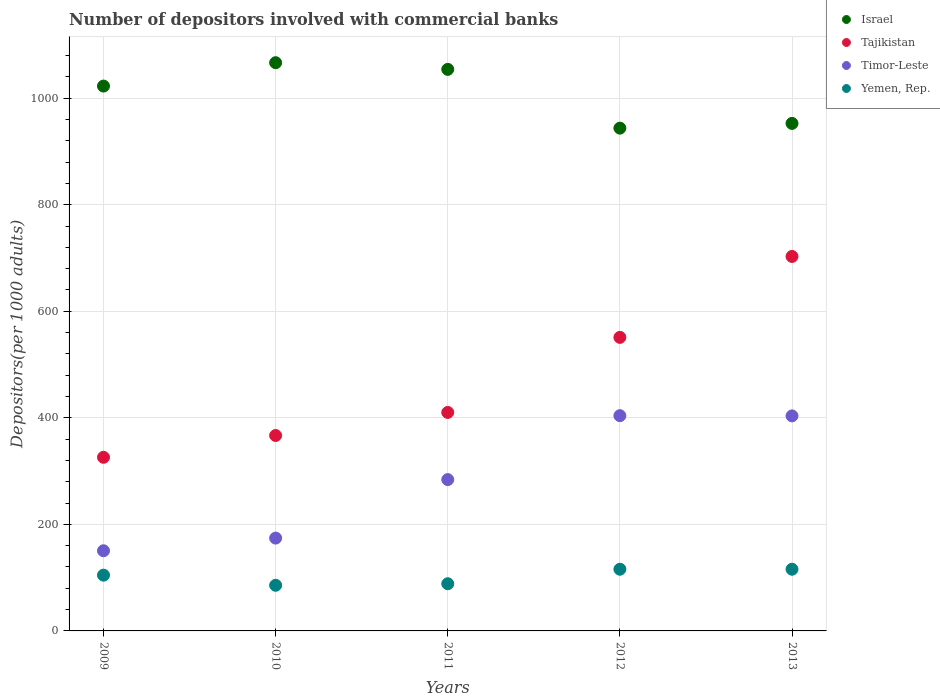How many different coloured dotlines are there?
Provide a succinct answer. 4. Is the number of dotlines equal to the number of legend labels?
Provide a short and direct response. Yes. What is the number of depositors involved with commercial banks in Tajikistan in 2011?
Ensure brevity in your answer.  410.1. Across all years, what is the maximum number of depositors involved with commercial banks in Israel?
Keep it short and to the point. 1066.56. Across all years, what is the minimum number of depositors involved with commercial banks in Yemen, Rep.?
Give a very brief answer. 85.68. In which year was the number of depositors involved with commercial banks in Timor-Leste maximum?
Ensure brevity in your answer.  2012. What is the total number of depositors involved with commercial banks in Yemen, Rep. in the graph?
Offer a terse response. 510.5. What is the difference between the number of depositors involved with commercial banks in Tajikistan in 2010 and that in 2012?
Give a very brief answer. -184.2. What is the difference between the number of depositors involved with commercial banks in Israel in 2011 and the number of depositors involved with commercial banks in Tajikistan in 2012?
Your response must be concise. 503.07. What is the average number of depositors involved with commercial banks in Timor-Leste per year?
Provide a short and direct response. 283.28. In the year 2012, what is the difference between the number of depositors involved with commercial banks in Timor-Leste and number of depositors involved with commercial banks in Yemen, Rep.?
Offer a terse response. 288.23. In how many years, is the number of depositors involved with commercial banks in Tajikistan greater than 1000?
Offer a terse response. 0. What is the ratio of the number of depositors involved with commercial banks in Timor-Leste in 2011 to that in 2012?
Offer a very short reply. 0.7. What is the difference between the highest and the second highest number of depositors involved with commercial banks in Timor-Leste?
Give a very brief answer. 0.38. What is the difference between the highest and the lowest number of depositors involved with commercial banks in Timor-Leste?
Offer a very short reply. 253.56. Is it the case that in every year, the sum of the number of depositors involved with commercial banks in Israel and number of depositors involved with commercial banks in Timor-Leste  is greater than the sum of number of depositors involved with commercial banks in Yemen, Rep. and number of depositors involved with commercial banks in Tajikistan?
Keep it short and to the point. Yes. Does the number of depositors involved with commercial banks in Israel monotonically increase over the years?
Your response must be concise. No. Is the number of depositors involved with commercial banks in Yemen, Rep. strictly less than the number of depositors involved with commercial banks in Timor-Leste over the years?
Keep it short and to the point. Yes. How many years are there in the graph?
Offer a terse response. 5. Where does the legend appear in the graph?
Your answer should be compact. Top right. What is the title of the graph?
Offer a terse response. Number of depositors involved with commercial banks. Does "Mexico" appear as one of the legend labels in the graph?
Make the answer very short. No. What is the label or title of the X-axis?
Offer a very short reply. Years. What is the label or title of the Y-axis?
Provide a succinct answer. Depositors(per 1000 adults). What is the Depositors(per 1000 adults) in Israel in 2009?
Offer a very short reply. 1022.7. What is the Depositors(per 1000 adults) of Tajikistan in 2009?
Offer a very short reply. 325.89. What is the Depositors(per 1000 adults) in Timor-Leste in 2009?
Your answer should be compact. 150.45. What is the Depositors(per 1000 adults) of Yemen, Rep. in 2009?
Your response must be concise. 104.68. What is the Depositors(per 1000 adults) of Israel in 2010?
Offer a terse response. 1066.56. What is the Depositors(per 1000 adults) in Tajikistan in 2010?
Make the answer very short. 366.8. What is the Depositors(per 1000 adults) of Timor-Leste in 2010?
Make the answer very short. 174.21. What is the Depositors(per 1000 adults) of Yemen, Rep. in 2010?
Give a very brief answer. 85.68. What is the Depositors(per 1000 adults) of Israel in 2011?
Ensure brevity in your answer.  1054.06. What is the Depositors(per 1000 adults) in Tajikistan in 2011?
Provide a short and direct response. 410.1. What is the Depositors(per 1000 adults) in Timor-Leste in 2011?
Your response must be concise. 284.07. What is the Depositors(per 1000 adults) in Yemen, Rep. in 2011?
Ensure brevity in your answer.  88.57. What is the Depositors(per 1000 adults) of Israel in 2012?
Your answer should be very brief. 943.72. What is the Depositors(per 1000 adults) in Tajikistan in 2012?
Keep it short and to the point. 550.99. What is the Depositors(per 1000 adults) in Timor-Leste in 2012?
Make the answer very short. 404.02. What is the Depositors(per 1000 adults) of Yemen, Rep. in 2012?
Keep it short and to the point. 115.78. What is the Depositors(per 1000 adults) in Israel in 2013?
Give a very brief answer. 952.62. What is the Depositors(per 1000 adults) in Tajikistan in 2013?
Provide a succinct answer. 702.89. What is the Depositors(per 1000 adults) in Timor-Leste in 2013?
Your answer should be very brief. 403.64. What is the Depositors(per 1000 adults) in Yemen, Rep. in 2013?
Your answer should be compact. 115.79. Across all years, what is the maximum Depositors(per 1000 adults) in Israel?
Provide a succinct answer. 1066.56. Across all years, what is the maximum Depositors(per 1000 adults) in Tajikistan?
Make the answer very short. 702.89. Across all years, what is the maximum Depositors(per 1000 adults) of Timor-Leste?
Provide a succinct answer. 404.02. Across all years, what is the maximum Depositors(per 1000 adults) in Yemen, Rep.?
Keep it short and to the point. 115.79. Across all years, what is the minimum Depositors(per 1000 adults) of Israel?
Give a very brief answer. 943.72. Across all years, what is the minimum Depositors(per 1000 adults) in Tajikistan?
Your answer should be compact. 325.89. Across all years, what is the minimum Depositors(per 1000 adults) in Timor-Leste?
Offer a terse response. 150.45. Across all years, what is the minimum Depositors(per 1000 adults) in Yemen, Rep.?
Keep it short and to the point. 85.68. What is the total Depositors(per 1000 adults) in Israel in the graph?
Ensure brevity in your answer.  5039.66. What is the total Depositors(per 1000 adults) in Tajikistan in the graph?
Your answer should be compact. 2356.67. What is the total Depositors(per 1000 adults) of Timor-Leste in the graph?
Ensure brevity in your answer.  1416.39. What is the total Depositors(per 1000 adults) in Yemen, Rep. in the graph?
Keep it short and to the point. 510.5. What is the difference between the Depositors(per 1000 adults) of Israel in 2009 and that in 2010?
Provide a short and direct response. -43.86. What is the difference between the Depositors(per 1000 adults) in Tajikistan in 2009 and that in 2010?
Your answer should be compact. -40.9. What is the difference between the Depositors(per 1000 adults) in Timor-Leste in 2009 and that in 2010?
Make the answer very short. -23.76. What is the difference between the Depositors(per 1000 adults) in Yemen, Rep. in 2009 and that in 2010?
Your answer should be compact. 19. What is the difference between the Depositors(per 1000 adults) in Israel in 2009 and that in 2011?
Offer a very short reply. -31.36. What is the difference between the Depositors(per 1000 adults) of Tajikistan in 2009 and that in 2011?
Make the answer very short. -84.21. What is the difference between the Depositors(per 1000 adults) of Timor-Leste in 2009 and that in 2011?
Your answer should be very brief. -133.62. What is the difference between the Depositors(per 1000 adults) of Yemen, Rep. in 2009 and that in 2011?
Provide a short and direct response. 16.11. What is the difference between the Depositors(per 1000 adults) of Israel in 2009 and that in 2012?
Your response must be concise. 78.98. What is the difference between the Depositors(per 1000 adults) in Tajikistan in 2009 and that in 2012?
Provide a succinct answer. -225.1. What is the difference between the Depositors(per 1000 adults) in Timor-Leste in 2009 and that in 2012?
Offer a very short reply. -253.56. What is the difference between the Depositors(per 1000 adults) in Yemen, Rep. in 2009 and that in 2012?
Make the answer very short. -11.1. What is the difference between the Depositors(per 1000 adults) of Israel in 2009 and that in 2013?
Your response must be concise. 70.08. What is the difference between the Depositors(per 1000 adults) of Tajikistan in 2009 and that in 2013?
Your answer should be compact. -377. What is the difference between the Depositors(per 1000 adults) of Timor-Leste in 2009 and that in 2013?
Your answer should be compact. -253.19. What is the difference between the Depositors(per 1000 adults) of Yemen, Rep. in 2009 and that in 2013?
Offer a very short reply. -11.11. What is the difference between the Depositors(per 1000 adults) in Israel in 2010 and that in 2011?
Offer a terse response. 12.5. What is the difference between the Depositors(per 1000 adults) of Tajikistan in 2010 and that in 2011?
Your answer should be compact. -43.3. What is the difference between the Depositors(per 1000 adults) of Timor-Leste in 2010 and that in 2011?
Provide a short and direct response. -109.86. What is the difference between the Depositors(per 1000 adults) of Yemen, Rep. in 2010 and that in 2011?
Your answer should be compact. -2.89. What is the difference between the Depositors(per 1000 adults) of Israel in 2010 and that in 2012?
Make the answer very short. 122.84. What is the difference between the Depositors(per 1000 adults) of Tajikistan in 2010 and that in 2012?
Your answer should be very brief. -184.2. What is the difference between the Depositors(per 1000 adults) of Timor-Leste in 2010 and that in 2012?
Offer a terse response. -229.8. What is the difference between the Depositors(per 1000 adults) of Yemen, Rep. in 2010 and that in 2012?
Your answer should be very brief. -30.1. What is the difference between the Depositors(per 1000 adults) in Israel in 2010 and that in 2013?
Provide a short and direct response. 113.94. What is the difference between the Depositors(per 1000 adults) of Tajikistan in 2010 and that in 2013?
Provide a short and direct response. -336.09. What is the difference between the Depositors(per 1000 adults) of Timor-Leste in 2010 and that in 2013?
Keep it short and to the point. -229.42. What is the difference between the Depositors(per 1000 adults) of Yemen, Rep. in 2010 and that in 2013?
Ensure brevity in your answer.  -30.11. What is the difference between the Depositors(per 1000 adults) in Israel in 2011 and that in 2012?
Make the answer very short. 110.33. What is the difference between the Depositors(per 1000 adults) in Tajikistan in 2011 and that in 2012?
Your response must be concise. -140.89. What is the difference between the Depositors(per 1000 adults) of Timor-Leste in 2011 and that in 2012?
Provide a short and direct response. -119.94. What is the difference between the Depositors(per 1000 adults) in Yemen, Rep. in 2011 and that in 2012?
Give a very brief answer. -27.21. What is the difference between the Depositors(per 1000 adults) of Israel in 2011 and that in 2013?
Keep it short and to the point. 101.44. What is the difference between the Depositors(per 1000 adults) of Tajikistan in 2011 and that in 2013?
Provide a succinct answer. -292.79. What is the difference between the Depositors(per 1000 adults) in Timor-Leste in 2011 and that in 2013?
Keep it short and to the point. -119.57. What is the difference between the Depositors(per 1000 adults) of Yemen, Rep. in 2011 and that in 2013?
Make the answer very short. -27.22. What is the difference between the Depositors(per 1000 adults) of Israel in 2012 and that in 2013?
Ensure brevity in your answer.  -8.9. What is the difference between the Depositors(per 1000 adults) in Tajikistan in 2012 and that in 2013?
Give a very brief answer. -151.9. What is the difference between the Depositors(per 1000 adults) in Timor-Leste in 2012 and that in 2013?
Ensure brevity in your answer.  0.38. What is the difference between the Depositors(per 1000 adults) of Yemen, Rep. in 2012 and that in 2013?
Your answer should be compact. -0.01. What is the difference between the Depositors(per 1000 adults) in Israel in 2009 and the Depositors(per 1000 adults) in Tajikistan in 2010?
Ensure brevity in your answer.  655.9. What is the difference between the Depositors(per 1000 adults) of Israel in 2009 and the Depositors(per 1000 adults) of Timor-Leste in 2010?
Your answer should be compact. 848.49. What is the difference between the Depositors(per 1000 adults) of Israel in 2009 and the Depositors(per 1000 adults) of Yemen, Rep. in 2010?
Make the answer very short. 937.02. What is the difference between the Depositors(per 1000 adults) of Tajikistan in 2009 and the Depositors(per 1000 adults) of Timor-Leste in 2010?
Your response must be concise. 151.68. What is the difference between the Depositors(per 1000 adults) of Tajikistan in 2009 and the Depositors(per 1000 adults) of Yemen, Rep. in 2010?
Offer a very short reply. 240.21. What is the difference between the Depositors(per 1000 adults) in Timor-Leste in 2009 and the Depositors(per 1000 adults) in Yemen, Rep. in 2010?
Offer a terse response. 64.77. What is the difference between the Depositors(per 1000 adults) of Israel in 2009 and the Depositors(per 1000 adults) of Tajikistan in 2011?
Give a very brief answer. 612.6. What is the difference between the Depositors(per 1000 adults) in Israel in 2009 and the Depositors(per 1000 adults) in Timor-Leste in 2011?
Offer a very short reply. 738.63. What is the difference between the Depositors(per 1000 adults) of Israel in 2009 and the Depositors(per 1000 adults) of Yemen, Rep. in 2011?
Keep it short and to the point. 934.13. What is the difference between the Depositors(per 1000 adults) in Tajikistan in 2009 and the Depositors(per 1000 adults) in Timor-Leste in 2011?
Make the answer very short. 41.82. What is the difference between the Depositors(per 1000 adults) of Tajikistan in 2009 and the Depositors(per 1000 adults) of Yemen, Rep. in 2011?
Your answer should be compact. 237.32. What is the difference between the Depositors(per 1000 adults) in Timor-Leste in 2009 and the Depositors(per 1000 adults) in Yemen, Rep. in 2011?
Ensure brevity in your answer.  61.88. What is the difference between the Depositors(per 1000 adults) in Israel in 2009 and the Depositors(per 1000 adults) in Tajikistan in 2012?
Your response must be concise. 471.71. What is the difference between the Depositors(per 1000 adults) in Israel in 2009 and the Depositors(per 1000 adults) in Timor-Leste in 2012?
Keep it short and to the point. 618.68. What is the difference between the Depositors(per 1000 adults) of Israel in 2009 and the Depositors(per 1000 adults) of Yemen, Rep. in 2012?
Make the answer very short. 906.92. What is the difference between the Depositors(per 1000 adults) in Tajikistan in 2009 and the Depositors(per 1000 adults) in Timor-Leste in 2012?
Provide a short and direct response. -78.12. What is the difference between the Depositors(per 1000 adults) in Tajikistan in 2009 and the Depositors(per 1000 adults) in Yemen, Rep. in 2012?
Provide a succinct answer. 210.11. What is the difference between the Depositors(per 1000 adults) of Timor-Leste in 2009 and the Depositors(per 1000 adults) of Yemen, Rep. in 2012?
Keep it short and to the point. 34.67. What is the difference between the Depositors(per 1000 adults) of Israel in 2009 and the Depositors(per 1000 adults) of Tajikistan in 2013?
Provide a short and direct response. 319.81. What is the difference between the Depositors(per 1000 adults) of Israel in 2009 and the Depositors(per 1000 adults) of Timor-Leste in 2013?
Give a very brief answer. 619.06. What is the difference between the Depositors(per 1000 adults) of Israel in 2009 and the Depositors(per 1000 adults) of Yemen, Rep. in 2013?
Offer a terse response. 906.91. What is the difference between the Depositors(per 1000 adults) of Tajikistan in 2009 and the Depositors(per 1000 adults) of Timor-Leste in 2013?
Provide a short and direct response. -77.75. What is the difference between the Depositors(per 1000 adults) of Tajikistan in 2009 and the Depositors(per 1000 adults) of Yemen, Rep. in 2013?
Your response must be concise. 210.1. What is the difference between the Depositors(per 1000 adults) in Timor-Leste in 2009 and the Depositors(per 1000 adults) in Yemen, Rep. in 2013?
Your response must be concise. 34.66. What is the difference between the Depositors(per 1000 adults) in Israel in 2010 and the Depositors(per 1000 adults) in Tajikistan in 2011?
Provide a short and direct response. 656.46. What is the difference between the Depositors(per 1000 adults) in Israel in 2010 and the Depositors(per 1000 adults) in Timor-Leste in 2011?
Make the answer very short. 782.49. What is the difference between the Depositors(per 1000 adults) of Israel in 2010 and the Depositors(per 1000 adults) of Yemen, Rep. in 2011?
Provide a succinct answer. 977.99. What is the difference between the Depositors(per 1000 adults) of Tajikistan in 2010 and the Depositors(per 1000 adults) of Timor-Leste in 2011?
Give a very brief answer. 82.72. What is the difference between the Depositors(per 1000 adults) in Tajikistan in 2010 and the Depositors(per 1000 adults) in Yemen, Rep. in 2011?
Offer a terse response. 278.23. What is the difference between the Depositors(per 1000 adults) of Timor-Leste in 2010 and the Depositors(per 1000 adults) of Yemen, Rep. in 2011?
Your answer should be compact. 85.64. What is the difference between the Depositors(per 1000 adults) of Israel in 2010 and the Depositors(per 1000 adults) of Tajikistan in 2012?
Provide a succinct answer. 515.57. What is the difference between the Depositors(per 1000 adults) of Israel in 2010 and the Depositors(per 1000 adults) of Timor-Leste in 2012?
Give a very brief answer. 662.54. What is the difference between the Depositors(per 1000 adults) in Israel in 2010 and the Depositors(per 1000 adults) in Yemen, Rep. in 2012?
Provide a succinct answer. 950.78. What is the difference between the Depositors(per 1000 adults) of Tajikistan in 2010 and the Depositors(per 1000 adults) of Timor-Leste in 2012?
Your answer should be compact. -37.22. What is the difference between the Depositors(per 1000 adults) of Tajikistan in 2010 and the Depositors(per 1000 adults) of Yemen, Rep. in 2012?
Your answer should be very brief. 251.01. What is the difference between the Depositors(per 1000 adults) in Timor-Leste in 2010 and the Depositors(per 1000 adults) in Yemen, Rep. in 2012?
Your response must be concise. 58.43. What is the difference between the Depositors(per 1000 adults) in Israel in 2010 and the Depositors(per 1000 adults) in Tajikistan in 2013?
Your response must be concise. 363.67. What is the difference between the Depositors(per 1000 adults) in Israel in 2010 and the Depositors(per 1000 adults) in Timor-Leste in 2013?
Ensure brevity in your answer.  662.92. What is the difference between the Depositors(per 1000 adults) of Israel in 2010 and the Depositors(per 1000 adults) of Yemen, Rep. in 2013?
Provide a short and direct response. 950.77. What is the difference between the Depositors(per 1000 adults) in Tajikistan in 2010 and the Depositors(per 1000 adults) in Timor-Leste in 2013?
Provide a succinct answer. -36.84. What is the difference between the Depositors(per 1000 adults) in Tajikistan in 2010 and the Depositors(per 1000 adults) in Yemen, Rep. in 2013?
Give a very brief answer. 251.01. What is the difference between the Depositors(per 1000 adults) in Timor-Leste in 2010 and the Depositors(per 1000 adults) in Yemen, Rep. in 2013?
Offer a very short reply. 58.43. What is the difference between the Depositors(per 1000 adults) in Israel in 2011 and the Depositors(per 1000 adults) in Tajikistan in 2012?
Your answer should be very brief. 503.07. What is the difference between the Depositors(per 1000 adults) in Israel in 2011 and the Depositors(per 1000 adults) in Timor-Leste in 2012?
Your response must be concise. 650.04. What is the difference between the Depositors(per 1000 adults) in Israel in 2011 and the Depositors(per 1000 adults) in Yemen, Rep. in 2012?
Provide a short and direct response. 938.27. What is the difference between the Depositors(per 1000 adults) in Tajikistan in 2011 and the Depositors(per 1000 adults) in Timor-Leste in 2012?
Provide a short and direct response. 6.08. What is the difference between the Depositors(per 1000 adults) of Tajikistan in 2011 and the Depositors(per 1000 adults) of Yemen, Rep. in 2012?
Provide a succinct answer. 294.32. What is the difference between the Depositors(per 1000 adults) of Timor-Leste in 2011 and the Depositors(per 1000 adults) of Yemen, Rep. in 2012?
Your answer should be compact. 168.29. What is the difference between the Depositors(per 1000 adults) in Israel in 2011 and the Depositors(per 1000 adults) in Tajikistan in 2013?
Offer a very short reply. 351.17. What is the difference between the Depositors(per 1000 adults) in Israel in 2011 and the Depositors(per 1000 adults) in Timor-Leste in 2013?
Ensure brevity in your answer.  650.42. What is the difference between the Depositors(per 1000 adults) of Israel in 2011 and the Depositors(per 1000 adults) of Yemen, Rep. in 2013?
Offer a very short reply. 938.27. What is the difference between the Depositors(per 1000 adults) in Tajikistan in 2011 and the Depositors(per 1000 adults) in Timor-Leste in 2013?
Make the answer very short. 6.46. What is the difference between the Depositors(per 1000 adults) of Tajikistan in 2011 and the Depositors(per 1000 adults) of Yemen, Rep. in 2013?
Give a very brief answer. 294.31. What is the difference between the Depositors(per 1000 adults) of Timor-Leste in 2011 and the Depositors(per 1000 adults) of Yemen, Rep. in 2013?
Make the answer very short. 168.28. What is the difference between the Depositors(per 1000 adults) in Israel in 2012 and the Depositors(per 1000 adults) in Tajikistan in 2013?
Give a very brief answer. 240.83. What is the difference between the Depositors(per 1000 adults) of Israel in 2012 and the Depositors(per 1000 adults) of Timor-Leste in 2013?
Give a very brief answer. 540.09. What is the difference between the Depositors(per 1000 adults) of Israel in 2012 and the Depositors(per 1000 adults) of Yemen, Rep. in 2013?
Ensure brevity in your answer.  827.94. What is the difference between the Depositors(per 1000 adults) of Tajikistan in 2012 and the Depositors(per 1000 adults) of Timor-Leste in 2013?
Offer a terse response. 147.35. What is the difference between the Depositors(per 1000 adults) in Tajikistan in 2012 and the Depositors(per 1000 adults) in Yemen, Rep. in 2013?
Ensure brevity in your answer.  435.2. What is the difference between the Depositors(per 1000 adults) of Timor-Leste in 2012 and the Depositors(per 1000 adults) of Yemen, Rep. in 2013?
Make the answer very short. 288.23. What is the average Depositors(per 1000 adults) of Israel per year?
Your response must be concise. 1007.93. What is the average Depositors(per 1000 adults) in Tajikistan per year?
Ensure brevity in your answer.  471.33. What is the average Depositors(per 1000 adults) of Timor-Leste per year?
Provide a succinct answer. 283.28. What is the average Depositors(per 1000 adults) in Yemen, Rep. per year?
Offer a terse response. 102.1. In the year 2009, what is the difference between the Depositors(per 1000 adults) in Israel and Depositors(per 1000 adults) in Tajikistan?
Your answer should be very brief. 696.81. In the year 2009, what is the difference between the Depositors(per 1000 adults) of Israel and Depositors(per 1000 adults) of Timor-Leste?
Provide a short and direct response. 872.25. In the year 2009, what is the difference between the Depositors(per 1000 adults) in Israel and Depositors(per 1000 adults) in Yemen, Rep.?
Provide a short and direct response. 918.02. In the year 2009, what is the difference between the Depositors(per 1000 adults) of Tajikistan and Depositors(per 1000 adults) of Timor-Leste?
Give a very brief answer. 175.44. In the year 2009, what is the difference between the Depositors(per 1000 adults) in Tajikistan and Depositors(per 1000 adults) in Yemen, Rep.?
Your answer should be very brief. 221.21. In the year 2009, what is the difference between the Depositors(per 1000 adults) of Timor-Leste and Depositors(per 1000 adults) of Yemen, Rep.?
Keep it short and to the point. 45.77. In the year 2010, what is the difference between the Depositors(per 1000 adults) of Israel and Depositors(per 1000 adults) of Tajikistan?
Provide a succinct answer. 699.76. In the year 2010, what is the difference between the Depositors(per 1000 adults) in Israel and Depositors(per 1000 adults) in Timor-Leste?
Make the answer very short. 892.35. In the year 2010, what is the difference between the Depositors(per 1000 adults) in Israel and Depositors(per 1000 adults) in Yemen, Rep.?
Provide a succinct answer. 980.88. In the year 2010, what is the difference between the Depositors(per 1000 adults) of Tajikistan and Depositors(per 1000 adults) of Timor-Leste?
Your answer should be compact. 192.58. In the year 2010, what is the difference between the Depositors(per 1000 adults) of Tajikistan and Depositors(per 1000 adults) of Yemen, Rep.?
Offer a very short reply. 281.11. In the year 2010, what is the difference between the Depositors(per 1000 adults) of Timor-Leste and Depositors(per 1000 adults) of Yemen, Rep.?
Your answer should be compact. 88.53. In the year 2011, what is the difference between the Depositors(per 1000 adults) of Israel and Depositors(per 1000 adults) of Tajikistan?
Your answer should be very brief. 643.96. In the year 2011, what is the difference between the Depositors(per 1000 adults) in Israel and Depositors(per 1000 adults) in Timor-Leste?
Ensure brevity in your answer.  769.99. In the year 2011, what is the difference between the Depositors(per 1000 adults) of Israel and Depositors(per 1000 adults) of Yemen, Rep.?
Give a very brief answer. 965.49. In the year 2011, what is the difference between the Depositors(per 1000 adults) in Tajikistan and Depositors(per 1000 adults) in Timor-Leste?
Provide a succinct answer. 126.03. In the year 2011, what is the difference between the Depositors(per 1000 adults) of Tajikistan and Depositors(per 1000 adults) of Yemen, Rep.?
Your answer should be very brief. 321.53. In the year 2011, what is the difference between the Depositors(per 1000 adults) of Timor-Leste and Depositors(per 1000 adults) of Yemen, Rep.?
Your answer should be very brief. 195.5. In the year 2012, what is the difference between the Depositors(per 1000 adults) of Israel and Depositors(per 1000 adults) of Tajikistan?
Keep it short and to the point. 392.73. In the year 2012, what is the difference between the Depositors(per 1000 adults) of Israel and Depositors(per 1000 adults) of Timor-Leste?
Ensure brevity in your answer.  539.71. In the year 2012, what is the difference between the Depositors(per 1000 adults) in Israel and Depositors(per 1000 adults) in Yemen, Rep.?
Your answer should be very brief. 827.94. In the year 2012, what is the difference between the Depositors(per 1000 adults) in Tajikistan and Depositors(per 1000 adults) in Timor-Leste?
Your answer should be very brief. 146.98. In the year 2012, what is the difference between the Depositors(per 1000 adults) in Tajikistan and Depositors(per 1000 adults) in Yemen, Rep.?
Your answer should be compact. 435.21. In the year 2012, what is the difference between the Depositors(per 1000 adults) of Timor-Leste and Depositors(per 1000 adults) of Yemen, Rep.?
Your response must be concise. 288.23. In the year 2013, what is the difference between the Depositors(per 1000 adults) in Israel and Depositors(per 1000 adults) in Tajikistan?
Your response must be concise. 249.73. In the year 2013, what is the difference between the Depositors(per 1000 adults) of Israel and Depositors(per 1000 adults) of Timor-Leste?
Offer a very short reply. 548.98. In the year 2013, what is the difference between the Depositors(per 1000 adults) of Israel and Depositors(per 1000 adults) of Yemen, Rep.?
Provide a succinct answer. 836.83. In the year 2013, what is the difference between the Depositors(per 1000 adults) in Tajikistan and Depositors(per 1000 adults) in Timor-Leste?
Make the answer very short. 299.25. In the year 2013, what is the difference between the Depositors(per 1000 adults) of Tajikistan and Depositors(per 1000 adults) of Yemen, Rep.?
Your answer should be compact. 587.1. In the year 2013, what is the difference between the Depositors(per 1000 adults) of Timor-Leste and Depositors(per 1000 adults) of Yemen, Rep.?
Keep it short and to the point. 287.85. What is the ratio of the Depositors(per 1000 adults) in Israel in 2009 to that in 2010?
Offer a very short reply. 0.96. What is the ratio of the Depositors(per 1000 adults) of Tajikistan in 2009 to that in 2010?
Give a very brief answer. 0.89. What is the ratio of the Depositors(per 1000 adults) of Timor-Leste in 2009 to that in 2010?
Ensure brevity in your answer.  0.86. What is the ratio of the Depositors(per 1000 adults) of Yemen, Rep. in 2009 to that in 2010?
Your response must be concise. 1.22. What is the ratio of the Depositors(per 1000 adults) of Israel in 2009 to that in 2011?
Give a very brief answer. 0.97. What is the ratio of the Depositors(per 1000 adults) of Tajikistan in 2009 to that in 2011?
Offer a terse response. 0.79. What is the ratio of the Depositors(per 1000 adults) in Timor-Leste in 2009 to that in 2011?
Offer a very short reply. 0.53. What is the ratio of the Depositors(per 1000 adults) of Yemen, Rep. in 2009 to that in 2011?
Make the answer very short. 1.18. What is the ratio of the Depositors(per 1000 adults) of Israel in 2009 to that in 2012?
Make the answer very short. 1.08. What is the ratio of the Depositors(per 1000 adults) of Tajikistan in 2009 to that in 2012?
Offer a terse response. 0.59. What is the ratio of the Depositors(per 1000 adults) of Timor-Leste in 2009 to that in 2012?
Provide a short and direct response. 0.37. What is the ratio of the Depositors(per 1000 adults) of Yemen, Rep. in 2009 to that in 2012?
Offer a very short reply. 0.9. What is the ratio of the Depositors(per 1000 adults) in Israel in 2009 to that in 2013?
Your response must be concise. 1.07. What is the ratio of the Depositors(per 1000 adults) of Tajikistan in 2009 to that in 2013?
Your answer should be very brief. 0.46. What is the ratio of the Depositors(per 1000 adults) in Timor-Leste in 2009 to that in 2013?
Offer a very short reply. 0.37. What is the ratio of the Depositors(per 1000 adults) of Yemen, Rep. in 2009 to that in 2013?
Provide a succinct answer. 0.9. What is the ratio of the Depositors(per 1000 adults) in Israel in 2010 to that in 2011?
Keep it short and to the point. 1.01. What is the ratio of the Depositors(per 1000 adults) of Tajikistan in 2010 to that in 2011?
Give a very brief answer. 0.89. What is the ratio of the Depositors(per 1000 adults) of Timor-Leste in 2010 to that in 2011?
Provide a succinct answer. 0.61. What is the ratio of the Depositors(per 1000 adults) in Yemen, Rep. in 2010 to that in 2011?
Your answer should be very brief. 0.97. What is the ratio of the Depositors(per 1000 adults) in Israel in 2010 to that in 2012?
Your answer should be compact. 1.13. What is the ratio of the Depositors(per 1000 adults) of Tajikistan in 2010 to that in 2012?
Ensure brevity in your answer.  0.67. What is the ratio of the Depositors(per 1000 adults) in Timor-Leste in 2010 to that in 2012?
Ensure brevity in your answer.  0.43. What is the ratio of the Depositors(per 1000 adults) of Yemen, Rep. in 2010 to that in 2012?
Keep it short and to the point. 0.74. What is the ratio of the Depositors(per 1000 adults) of Israel in 2010 to that in 2013?
Give a very brief answer. 1.12. What is the ratio of the Depositors(per 1000 adults) in Tajikistan in 2010 to that in 2013?
Provide a short and direct response. 0.52. What is the ratio of the Depositors(per 1000 adults) in Timor-Leste in 2010 to that in 2013?
Provide a succinct answer. 0.43. What is the ratio of the Depositors(per 1000 adults) in Yemen, Rep. in 2010 to that in 2013?
Keep it short and to the point. 0.74. What is the ratio of the Depositors(per 1000 adults) in Israel in 2011 to that in 2012?
Provide a succinct answer. 1.12. What is the ratio of the Depositors(per 1000 adults) of Tajikistan in 2011 to that in 2012?
Provide a short and direct response. 0.74. What is the ratio of the Depositors(per 1000 adults) of Timor-Leste in 2011 to that in 2012?
Give a very brief answer. 0.7. What is the ratio of the Depositors(per 1000 adults) of Yemen, Rep. in 2011 to that in 2012?
Offer a terse response. 0.77. What is the ratio of the Depositors(per 1000 adults) in Israel in 2011 to that in 2013?
Your answer should be compact. 1.11. What is the ratio of the Depositors(per 1000 adults) in Tajikistan in 2011 to that in 2013?
Provide a succinct answer. 0.58. What is the ratio of the Depositors(per 1000 adults) in Timor-Leste in 2011 to that in 2013?
Make the answer very short. 0.7. What is the ratio of the Depositors(per 1000 adults) of Yemen, Rep. in 2011 to that in 2013?
Ensure brevity in your answer.  0.76. What is the ratio of the Depositors(per 1000 adults) of Tajikistan in 2012 to that in 2013?
Provide a succinct answer. 0.78. What is the ratio of the Depositors(per 1000 adults) of Timor-Leste in 2012 to that in 2013?
Provide a short and direct response. 1. What is the difference between the highest and the second highest Depositors(per 1000 adults) in Israel?
Keep it short and to the point. 12.5. What is the difference between the highest and the second highest Depositors(per 1000 adults) in Tajikistan?
Your answer should be very brief. 151.9. What is the difference between the highest and the second highest Depositors(per 1000 adults) in Timor-Leste?
Give a very brief answer. 0.38. What is the difference between the highest and the second highest Depositors(per 1000 adults) in Yemen, Rep.?
Offer a very short reply. 0.01. What is the difference between the highest and the lowest Depositors(per 1000 adults) of Israel?
Provide a succinct answer. 122.84. What is the difference between the highest and the lowest Depositors(per 1000 adults) of Tajikistan?
Offer a terse response. 377. What is the difference between the highest and the lowest Depositors(per 1000 adults) of Timor-Leste?
Your answer should be compact. 253.56. What is the difference between the highest and the lowest Depositors(per 1000 adults) of Yemen, Rep.?
Ensure brevity in your answer.  30.11. 